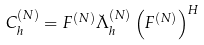Convert formula to latex. <formula><loc_0><loc_0><loc_500><loc_500>C _ { h } ^ { ( N ) } & = F ^ { ( N ) } \breve { \Lambda } _ { h } ^ { ( N ) } \left ( F ^ { ( N ) } \right ) ^ { H }</formula> 